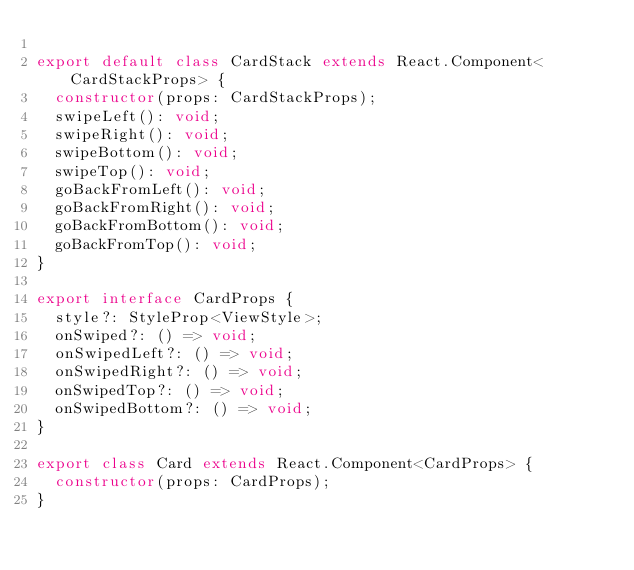<code> <loc_0><loc_0><loc_500><loc_500><_TypeScript_>
export default class CardStack extends React.Component<CardStackProps> {
  constructor(props: CardStackProps);
  swipeLeft(): void;
  swipeRight(): void;
  swipeBottom(): void;
  swipeTop(): void;
  goBackFromLeft(): void;
  goBackFromRight(): void;
  goBackFromBottom(): void;
  goBackFromTop(): void;
}

export interface CardProps {
  style?: StyleProp<ViewStyle>;
  onSwiped?: () => void;
  onSwipedLeft?: () => void;
  onSwipedRight?: () => void;
  onSwipedTop?: () => void;
  onSwipedBottom?: () => void;
}

export class Card extends React.Component<CardProps> {
  constructor(props: CardProps);
}</code> 